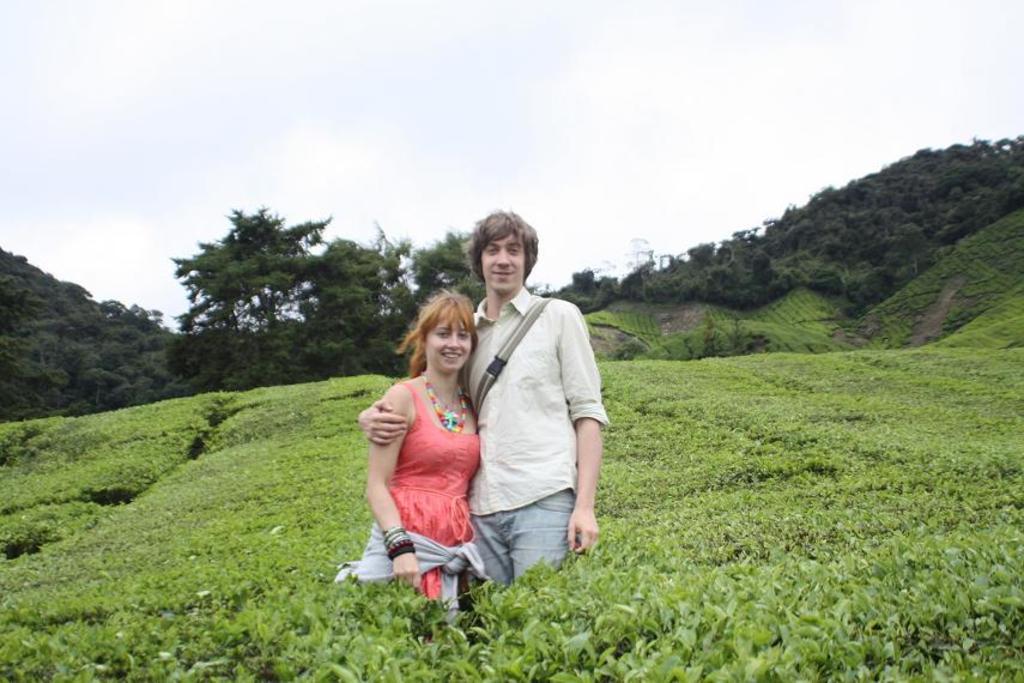In one or two sentences, can you explain what this image depicts? In this picture, there is a woman and a man. Woman is wearing a peach color dress and man is wearing a white shirt and blue jeans. Around them, there are plants. In the background, there are hills with trees. On the top, there is sky. 